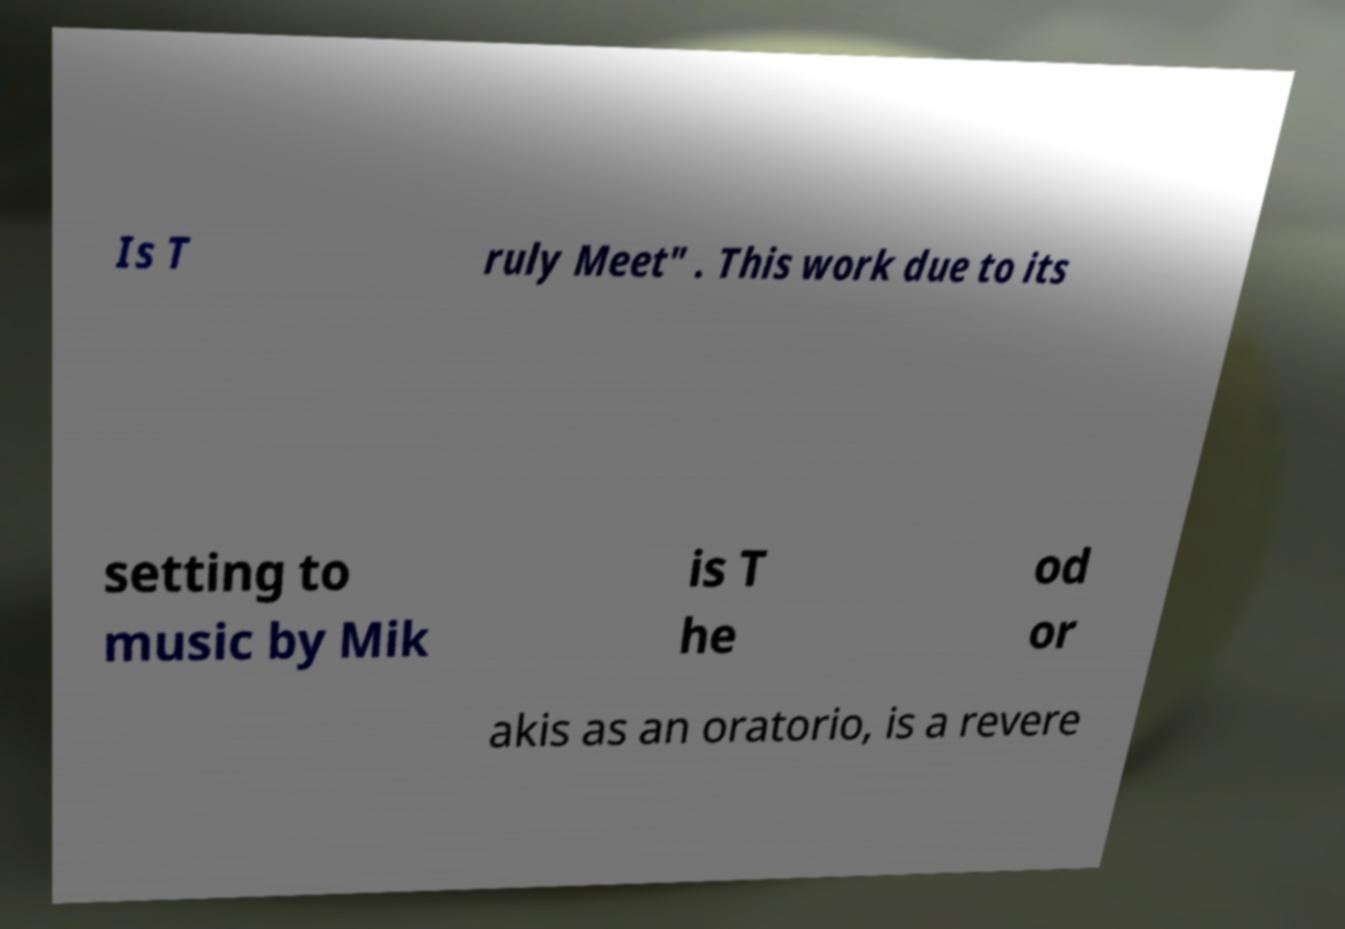What messages or text are displayed in this image? I need them in a readable, typed format. Is T ruly Meet" . This work due to its setting to music by Mik is T he od or akis as an oratorio, is a revere 